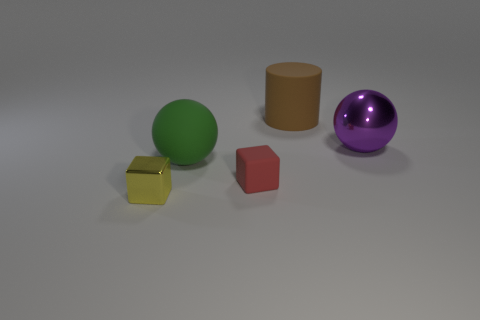How many things are either tiny objects or large rubber things that are to the right of the green matte sphere?
Offer a very short reply. 3. What size is the object that is in front of the big green thing and to the left of the tiny red matte object?
Give a very brief answer. Small. Are there more objects behind the large purple shiny object than large matte cylinders that are in front of the yellow metal object?
Provide a short and direct response. Yes. Does the small rubber thing have the same shape as the metal object that is right of the yellow cube?
Your answer should be very brief. No. How many other objects are there of the same shape as the red matte thing?
Provide a succinct answer. 1. There is a thing that is left of the purple metallic object and behind the big green sphere; what is its color?
Your response must be concise. Brown. The big metal thing is what color?
Your response must be concise. Purple. Are the large purple ball and the tiny thing right of the tiny yellow shiny thing made of the same material?
Your response must be concise. No. The other object that is made of the same material as the yellow thing is what shape?
Offer a terse response. Sphere. What is the color of the other cube that is the same size as the red cube?
Keep it short and to the point. Yellow. 